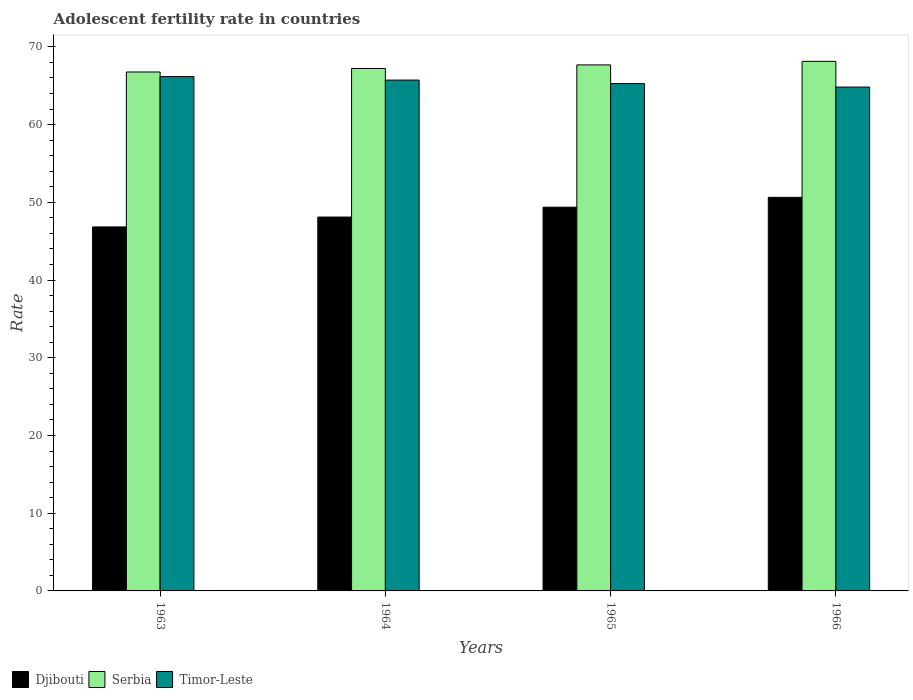How many different coloured bars are there?
Make the answer very short. 3. Are the number of bars on each tick of the X-axis equal?
Your answer should be very brief. Yes. How many bars are there on the 4th tick from the left?
Offer a very short reply. 3. How many bars are there on the 4th tick from the right?
Give a very brief answer. 3. What is the label of the 4th group of bars from the left?
Keep it short and to the point. 1966. In how many cases, is the number of bars for a given year not equal to the number of legend labels?
Provide a succinct answer. 0. What is the adolescent fertility rate in Timor-Leste in 1964?
Provide a short and direct response. 65.73. Across all years, what is the maximum adolescent fertility rate in Serbia?
Provide a succinct answer. 68.14. Across all years, what is the minimum adolescent fertility rate in Serbia?
Offer a terse response. 66.77. In which year was the adolescent fertility rate in Djibouti maximum?
Your answer should be very brief. 1966. In which year was the adolescent fertility rate in Timor-Leste minimum?
Your answer should be very brief. 1966. What is the total adolescent fertility rate in Djibouti in the graph?
Offer a very short reply. 194.96. What is the difference between the adolescent fertility rate in Serbia in 1964 and that in 1966?
Make the answer very short. -0.91. What is the difference between the adolescent fertility rate in Djibouti in 1963 and the adolescent fertility rate in Timor-Leste in 1964?
Offer a terse response. -18.89. What is the average adolescent fertility rate in Serbia per year?
Offer a very short reply. 67.45. In the year 1963, what is the difference between the adolescent fertility rate in Timor-Leste and adolescent fertility rate in Djibouti?
Your response must be concise. 19.34. In how many years, is the adolescent fertility rate in Djibouti greater than 68?
Provide a succinct answer. 0. What is the ratio of the adolescent fertility rate in Timor-Leste in 1963 to that in 1964?
Ensure brevity in your answer.  1.01. What is the difference between the highest and the second highest adolescent fertility rate in Serbia?
Offer a very short reply. 0.46. What is the difference between the highest and the lowest adolescent fertility rate in Serbia?
Provide a succinct answer. 1.37. What does the 3rd bar from the left in 1963 represents?
Your answer should be very brief. Timor-Leste. What does the 3rd bar from the right in 1963 represents?
Your answer should be very brief. Djibouti. Is it the case that in every year, the sum of the adolescent fertility rate in Timor-Leste and adolescent fertility rate in Serbia is greater than the adolescent fertility rate in Djibouti?
Make the answer very short. Yes. How many bars are there?
Offer a very short reply. 12. How many years are there in the graph?
Offer a very short reply. 4. What is the difference between two consecutive major ticks on the Y-axis?
Ensure brevity in your answer.  10. Are the values on the major ticks of Y-axis written in scientific E-notation?
Give a very brief answer. No. Does the graph contain any zero values?
Provide a succinct answer. No. Does the graph contain grids?
Ensure brevity in your answer.  No. Where does the legend appear in the graph?
Your answer should be very brief. Bottom left. How many legend labels are there?
Offer a terse response. 3. How are the legend labels stacked?
Ensure brevity in your answer.  Horizontal. What is the title of the graph?
Ensure brevity in your answer.  Adolescent fertility rate in countries. What is the label or title of the Y-axis?
Provide a short and direct response. Rate. What is the Rate of Djibouti in 1963?
Your answer should be compact. 46.84. What is the Rate in Serbia in 1963?
Keep it short and to the point. 66.77. What is the Rate of Timor-Leste in 1963?
Give a very brief answer. 66.18. What is the Rate of Djibouti in 1964?
Make the answer very short. 48.1. What is the Rate in Serbia in 1964?
Make the answer very short. 67.23. What is the Rate in Timor-Leste in 1964?
Provide a short and direct response. 65.73. What is the Rate of Djibouti in 1965?
Make the answer very short. 49.37. What is the Rate in Serbia in 1965?
Offer a very short reply. 67.68. What is the Rate of Timor-Leste in 1965?
Provide a succinct answer. 65.28. What is the Rate of Djibouti in 1966?
Make the answer very short. 50.64. What is the Rate of Serbia in 1966?
Make the answer very short. 68.14. What is the Rate in Timor-Leste in 1966?
Keep it short and to the point. 64.83. Across all years, what is the maximum Rate of Djibouti?
Your answer should be very brief. 50.64. Across all years, what is the maximum Rate in Serbia?
Keep it short and to the point. 68.14. Across all years, what is the maximum Rate in Timor-Leste?
Ensure brevity in your answer.  66.18. Across all years, what is the minimum Rate of Djibouti?
Offer a very short reply. 46.84. Across all years, what is the minimum Rate in Serbia?
Keep it short and to the point. 66.77. Across all years, what is the minimum Rate of Timor-Leste?
Offer a very short reply. 64.83. What is the total Rate of Djibouti in the graph?
Ensure brevity in your answer.  194.96. What is the total Rate in Serbia in the graph?
Give a very brief answer. 269.82. What is the total Rate of Timor-Leste in the graph?
Provide a succinct answer. 262.01. What is the difference between the Rate in Djibouti in 1963 and that in 1964?
Make the answer very short. -1.27. What is the difference between the Rate of Serbia in 1963 and that in 1964?
Provide a succinct answer. -0.46. What is the difference between the Rate of Timor-Leste in 1963 and that in 1964?
Ensure brevity in your answer.  0.45. What is the difference between the Rate in Djibouti in 1963 and that in 1965?
Make the answer very short. -2.54. What is the difference between the Rate of Serbia in 1963 and that in 1965?
Give a very brief answer. -0.91. What is the difference between the Rate of Timor-Leste in 1963 and that in 1965?
Your answer should be compact. 0.9. What is the difference between the Rate in Djibouti in 1963 and that in 1966?
Keep it short and to the point. -3.81. What is the difference between the Rate of Serbia in 1963 and that in 1966?
Provide a succinct answer. -1.37. What is the difference between the Rate in Timor-Leste in 1963 and that in 1966?
Give a very brief answer. 1.35. What is the difference between the Rate in Djibouti in 1964 and that in 1965?
Offer a very short reply. -1.27. What is the difference between the Rate of Serbia in 1964 and that in 1965?
Keep it short and to the point. -0.46. What is the difference between the Rate of Timor-Leste in 1964 and that in 1965?
Provide a short and direct response. 0.45. What is the difference between the Rate in Djibouti in 1964 and that in 1966?
Provide a short and direct response. -2.54. What is the difference between the Rate in Serbia in 1964 and that in 1966?
Offer a very short reply. -0.91. What is the difference between the Rate in Timor-Leste in 1964 and that in 1966?
Ensure brevity in your answer.  0.9. What is the difference between the Rate in Djibouti in 1965 and that in 1966?
Ensure brevity in your answer.  -1.27. What is the difference between the Rate of Serbia in 1965 and that in 1966?
Provide a short and direct response. -0.46. What is the difference between the Rate in Timor-Leste in 1965 and that in 1966?
Offer a terse response. 0.45. What is the difference between the Rate in Djibouti in 1963 and the Rate in Serbia in 1964?
Your answer should be very brief. -20.39. What is the difference between the Rate of Djibouti in 1963 and the Rate of Timor-Leste in 1964?
Offer a terse response. -18.89. What is the difference between the Rate of Serbia in 1963 and the Rate of Timor-Leste in 1964?
Provide a succinct answer. 1.04. What is the difference between the Rate in Djibouti in 1963 and the Rate in Serbia in 1965?
Your response must be concise. -20.85. What is the difference between the Rate of Djibouti in 1963 and the Rate of Timor-Leste in 1965?
Give a very brief answer. -18.44. What is the difference between the Rate of Serbia in 1963 and the Rate of Timor-Leste in 1965?
Provide a succinct answer. 1.49. What is the difference between the Rate in Djibouti in 1963 and the Rate in Serbia in 1966?
Ensure brevity in your answer.  -21.3. What is the difference between the Rate in Djibouti in 1963 and the Rate in Timor-Leste in 1966?
Provide a short and direct response. -17.99. What is the difference between the Rate in Serbia in 1963 and the Rate in Timor-Leste in 1966?
Your answer should be compact. 1.94. What is the difference between the Rate in Djibouti in 1964 and the Rate in Serbia in 1965?
Provide a short and direct response. -19.58. What is the difference between the Rate in Djibouti in 1964 and the Rate in Timor-Leste in 1965?
Your answer should be very brief. -17.17. What is the difference between the Rate in Serbia in 1964 and the Rate in Timor-Leste in 1965?
Provide a short and direct response. 1.95. What is the difference between the Rate in Djibouti in 1964 and the Rate in Serbia in 1966?
Offer a very short reply. -20.03. What is the difference between the Rate of Djibouti in 1964 and the Rate of Timor-Leste in 1966?
Make the answer very short. -16.72. What is the difference between the Rate in Serbia in 1964 and the Rate in Timor-Leste in 1966?
Keep it short and to the point. 2.4. What is the difference between the Rate of Djibouti in 1965 and the Rate of Serbia in 1966?
Offer a terse response. -18.76. What is the difference between the Rate in Djibouti in 1965 and the Rate in Timor-Leste in 1966?
Keep it short and to the point. -15.45. What is the difference between the Rate in Serbia in 1965 and the Rate in Timor-Leste in 1966?
Give a very brief answer. 2.85. What is the average Rate of Djibouti per year?
Your answer should be very brief. 48.74. What is the average Rate in Serbia per year?
Keep it short and to the point. 67.45. What is the average Rate of Timor-Leste per year?
Your answer should be compact. 65.5. In the year 1963, what is the difference between the Rate of Djibouti and Rate of Serbia?
Give a very brief answer. -19.93. In the year 1963, what is the difference between the Rate in Djibouti and Rate in Timor-Leste?
Provide a short and direct response. -19.34. In the year 1963, what is the difference between the Rate of Serbia and Rate of Timor-Leste?
Your answer should be compact. 0.59. In the year 1964, what is the difference between the Rate in Djibouti and Rate in Serbia?
Provide a succinct answer. -19.12. In the year 1964, what is the difference between the Rate of Djibouti and Rate of Timor-Leste?
Offer a terse response. -17.62. In the year 1964, what is the difference between the Rate of Serbia and Rate of Timor-Leste?
Keep it short and to the point. 1.5. In the year 1965, what is the difference between the Rate in Djibouti and Rate in Serbia?
Give a very brief answer. -18.31. In the year 1965, what is the difference between the Rate of Djibouti and Rate of Timor-Leste?
Give a very brief answer. -15.9. In the year 1965, what is the difference between the Rate of Serbia and Rate of Timor-Leste?
Provide a succinct answer. 2.4. In the year 1966, what is the difference between the Rate of Djibouti and Rate of Serbia?
Your answer should be compact. -17.5. In the year 1966, what is the difference between the Rate of Djibouti and Rate of Timor-Leste?
Provide a short and direct response. -14.19. In the year 1966, what is the difference between the Rate in Serbia and Rate in Timor-Leste?
Offer a terse response. 3.31. What is the ratio of the Rate in Djibouti in 1963 to that in 1964?
Offer a very short reply. 0.97. What is the ratio of the Rate in Timor-Leste in 1963 to that in 1964?
Offer a very short reply. 1.01. What is the ratio of the Rate in Djibouti in 1963 to that in 1965?
Offer a terse response. 0.95. What is the ratio of the Rate in Serbia in 1963 to that in 1965?
Offer a terse response. 0.99. What is the ratio of the Rate of Timor-Leste in 1963 to that in 1965?
Ensure brevity in your answer.  1.01. What is the ratio of the Rate in Djibouti in 1963 to that in 1966?
Your answer should be compact. 0.92. What is the ratio of the Rate in Serbia in 1963 to that in 1966?
Provide a succinct answer. 0.98. What is the ratio of the Rate of Timor-Leste in 1963 to that in 1966?
Your answer should be compact. 1.02. What is the ratio of the Rate of Djibouti in 1964 to that in 1965?
Make the answer very short. 0.97. What is the ratio of the Rate in Timor-Leste in 1964 to that in 1965?
Offer a very short reply. 1.01. What is the ratio of the Rate in Djibouti in 1964 to that in 1966?
Your answer should be very brief. 0.95. What is the ratio of the Rate in Serbia in 1964 to that in 1966?
Keep it short and to the point. 0.99. What is the ratio of the Rate in Timor-Leste in 1964 to that in 1966?
Offer a very short reply. 1.01. What is the ratio of the Rate of Djibouti in 1965 to that in 1966?
Provide a short and direct response. 0.97. What is the ratio of the Rate in Serbia in 1965 to that in 1966?
Your answer should be very brief. 0.99. What is the ratio of the Rate in Timor-Leste in 1965 to that in 1966?
Your response must be concise. 1.01. What is the difference between the highest and the second highest Rate of Djibouti?
Keep it short and to the point. 1.27. What is the difference between the highest and the second highest Rate in Serbia?
Provide a short and direct response. 0.46. What is the difference between the highest and the second highest Rate of Timor-Leste?
Make the answer very short. 0.45. What is the difference between the highest and the lowest Rate in Djibouti?
Your answer should be very brief. 3.81. What is the difference between the highest and the lowest Rate of Serbia?
Ensure brevity in your answer.  1.37. What is the difference between the highest and the lowest Rate in Timor-Leste?
Your answer should be compact. 1.35. 